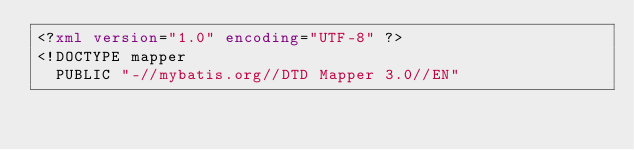<code> <loc_0><loc_0><loc_500><loc_500><_XML_><?xml version="1.0" encoding="UTF-8" ?>
<!DOCTYPE mapper
  PUBLIC "-//mybatis.org//DTD Mapper 3.0//EN"</code> 